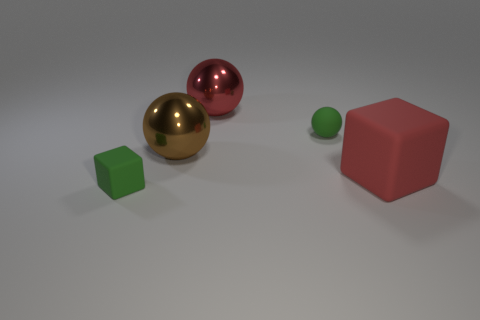Subtract all large balls. How many balls are left? 1 Add 3 small matte cubes. How many objects exist? 8 Subtract all spheres. How many objects are left? 2 Add 1 brown shiny things. How many brown shiny things exist? 2 Subtract 0 cyan cylinders. How many objects are left? 5 Subtract all large cyan metallic spheres. Subtract all rubber balls. How many objects are left? 4 Add 2 red metallic objects. How many red metallic objects are left? 3 